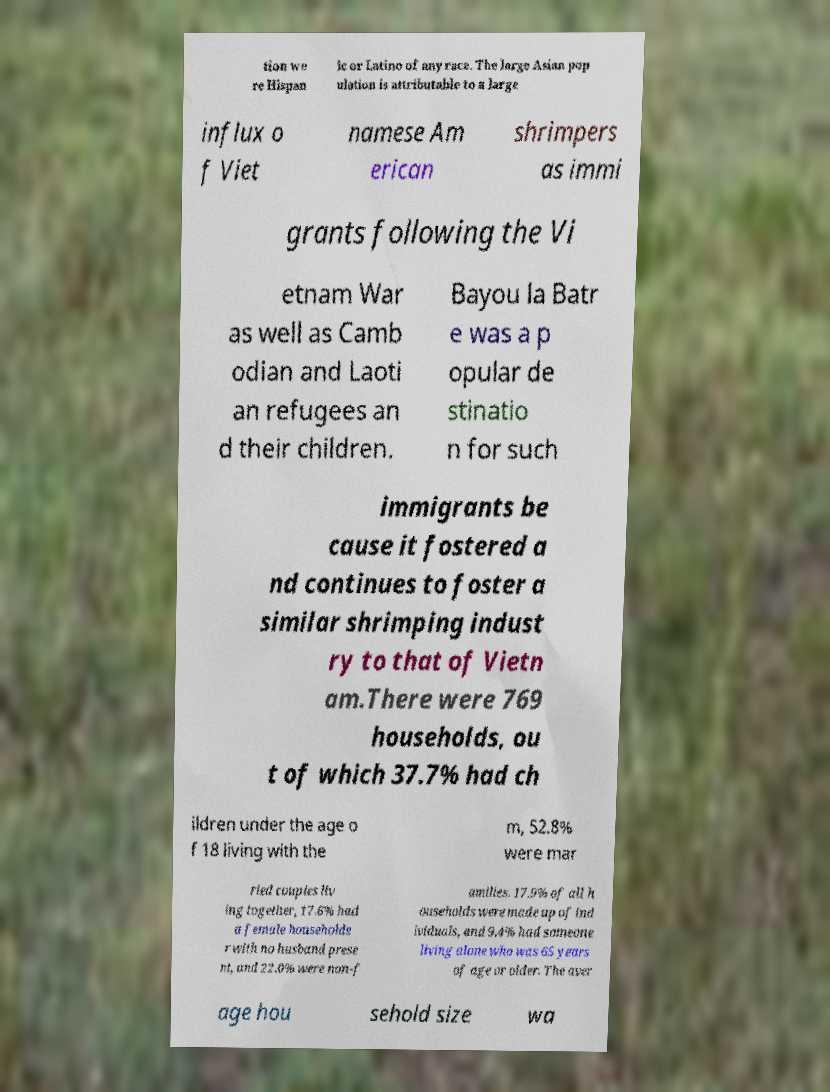Can you read and provide the text displayed in the image?This photo seems to have some interesting text. Can you extract and type it out for me? tion we re Hispan ic or Latino of any race. The large Asian pop ulation is attributable to a large influx o f Viet namese Am erican shrimpers as immi grants following the Vi etnam War as well as Camb odian and Laoti an refugees an d their children. Bayou la Batr e was a p opular de stinatio n for such immigrants be cause it fostered a nd continues to foster a similar shrimping indust ry to that of Vietn am.There were 769 households, ou t of which 37.7% had ch ildren under the age o f 18 living with the m, 52.8% were mar ried couples liv ing together, 17.6% had a female householde r with no husband prese nt, and 22.0% were non-f amilies. 17.9% of all h ouseholds were made up of ind ividuals, and 9.4% had someone living alone who was 65 years of age or older. The aver age hou sehold size wa 